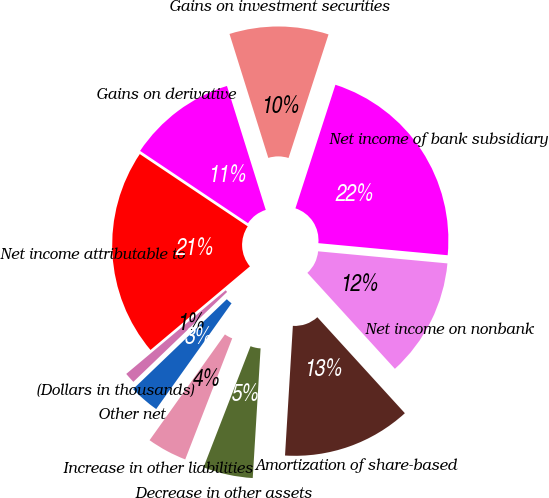<chart> <loc_0><loc_0><loc_500><loc_500><pie_chart><fcel>(Dollars in thousands)<fcel>Net income attributable to<fcel>Gains on derivative<fcel>Gains on investment securities<fcel>Net income of bank subsidiary<fcel>Net income on nonbank<fcel>Amortization of share-based<fcel>Decrease in other assets<fcel>Increase in other liabilities<fcel>Other net<nl><fcel>1.04%<fcel>20.52%<fcel>10.78%<fcel>9.81%<fcel>21.5%<fcel>11.75%<fcel>12.73%<fcel>4.93%<fcel>3.96%<fcel>2.98%<nl></chart> 